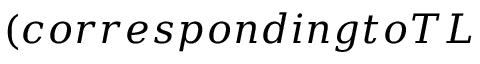Convert formula to latex. <formula><loc_0><loc_0><loc_500><loc_500>( c o r r e s p o n d i n g t o T L</formula> 